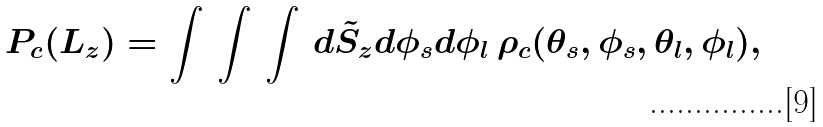<formula> <loc_0><loc_0><loc_500><loc_500>P _ { c } ( L _ { z } ) = \int \, \int \, \int \, d \tilde { S } _ { z } d \phi _ { s } d \phi _ { l } \, \rho _ { c } ( \theta _ { s } , \phi _ { s } , \theta _ { l } , \phi _ { l } ) ,</formula> 